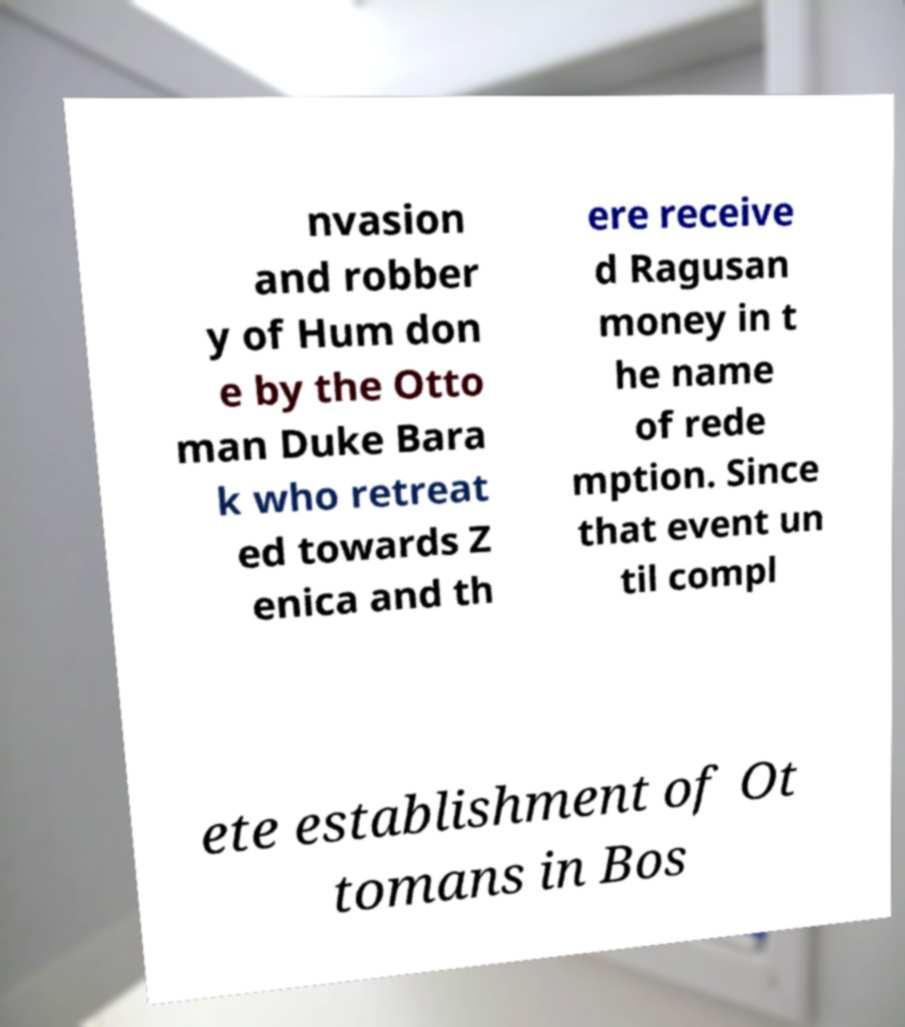Please identify and transcribe the text found in this image. nvasion and robber y of Hum don e by the Otto man Duke Bara k who retreat ed towards Z enica and th ere receive d Ragusan money in t he name of rede mption. Since that event un til compl ete establishment of Ot tomans in Bos 